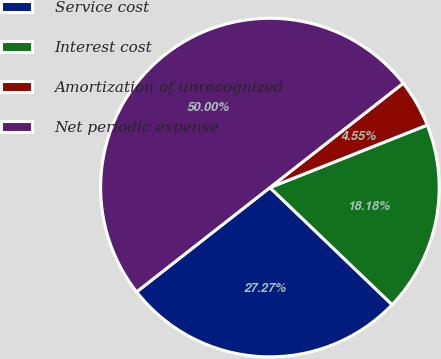Convert chart. <chart><loc_0><loc_0><loc_500><loc_500><pie_chart><fcel>Service cost<fcel>Interest cost<fcel>Amortization of unrecognized<fcel>Net periodic expense<nl><fcel>27.27%<fcel>18.18%<fcel>4.55%<fcel>50.0%<nl></chart> 